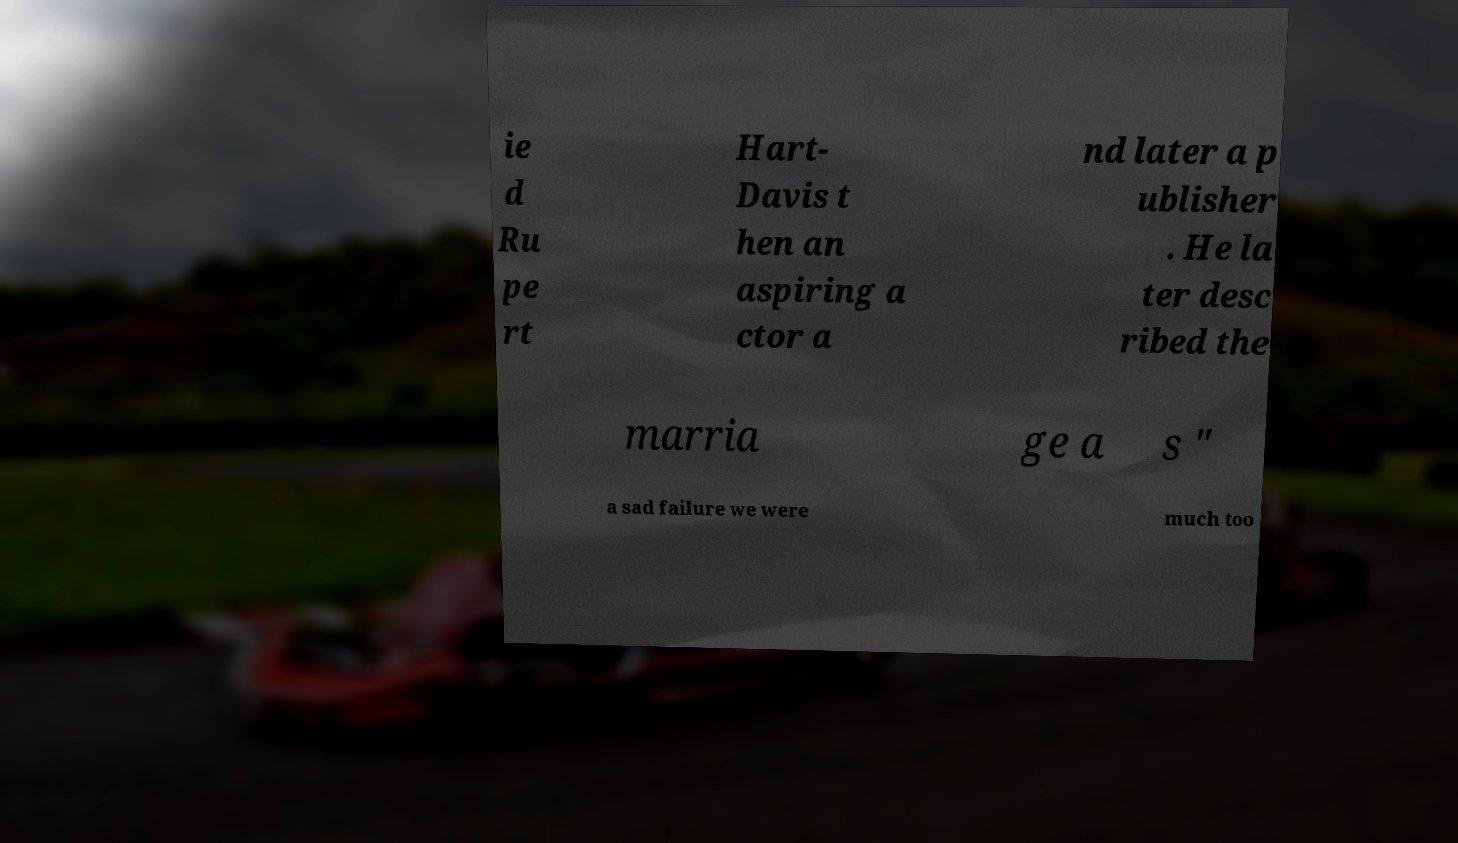For documentation purposes, I need the text within this image transcribed. Could you provide that? ie d Ru pe rt Hart- Davis t hen an aspiring a ctor a nd later a p ublisher . He la ter desc ribed the marria ge a s " a sad failure we were much too 